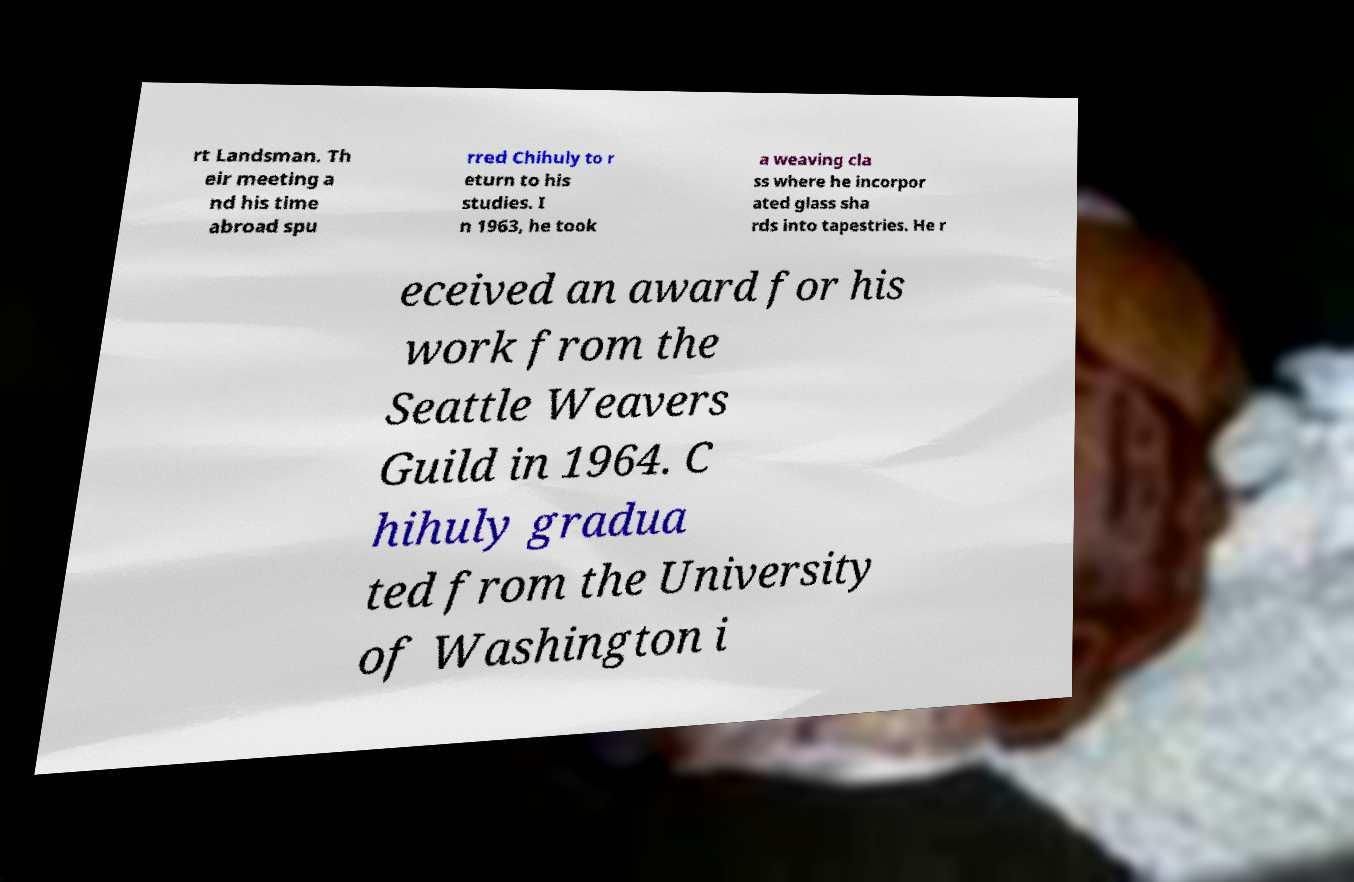For documentation purposes, I need the text within this image transcribed. Could you provide that? rt Landsman. Th eir meeting a nd his time abroad spu rred Chihuly to r eturn to his studies. I n 1963, he took a weaving cla ss where he incorpor ated glass sha rds into tapestries. He r eceived an award for his work from the Seattle Weavers Guild in 1964. C hihuly gradua ted from the University of Washington i 